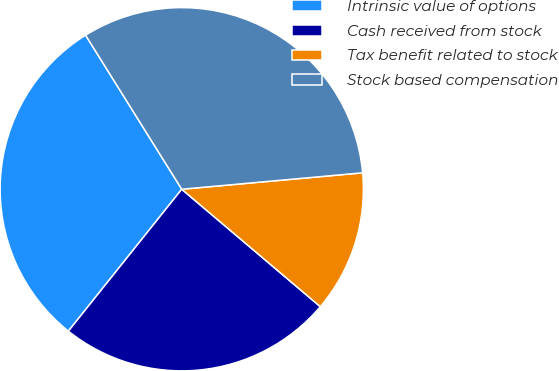Convert chart. <chart><loc_0><loc_0><loc_500><loc_500><pie_chart><fcel>Intrinsic value of options<fcel>Cash received from stock<fcel>Tax benefit related to stock<fcel>Stock based compensation<nl><fcel>30.39%<fcel>24.54%<fcel>12.63%<fcel>32.44%<nl></chart> 